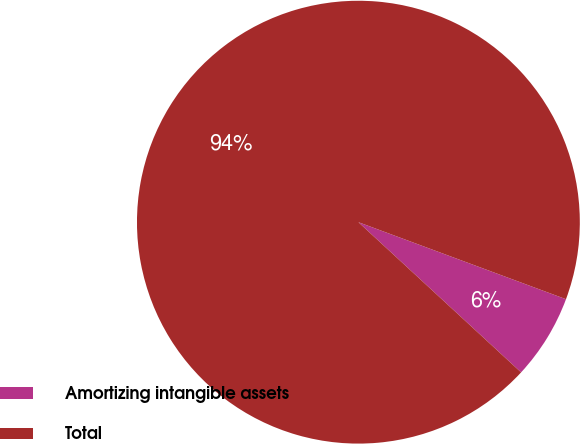Convert chart to OTSL. <chart><loc_0><loc_0><loc_500><loc_500><pie_chart><fcel>Amortizing intangible assets<fcel>Total<nl><fcel>6.21%<fcel>93.79%<nl></chart> 